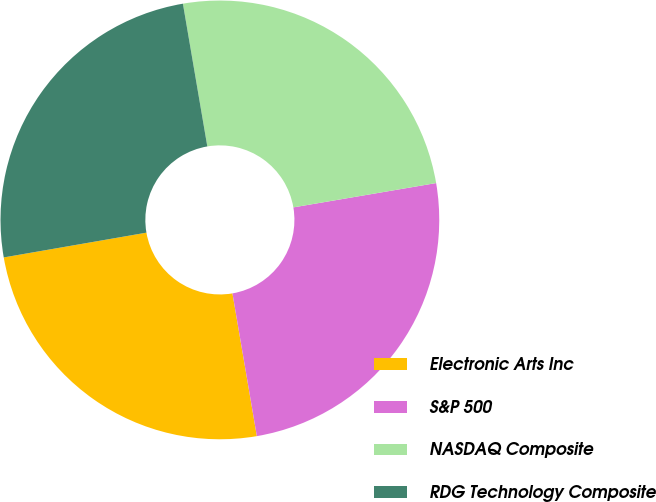<chart> <loc_0><loc_0><loc_500><loc_500><pie_chart><fcel>Electronic Arts Inc<fcel>S&P 500<fcel>NASDAQ Composite<fcel>RDG Technology Composite<nl><fcel>24.96%<fcel>24.99%<fcel>25.01%<fcel>25.04%<nl></chart> 